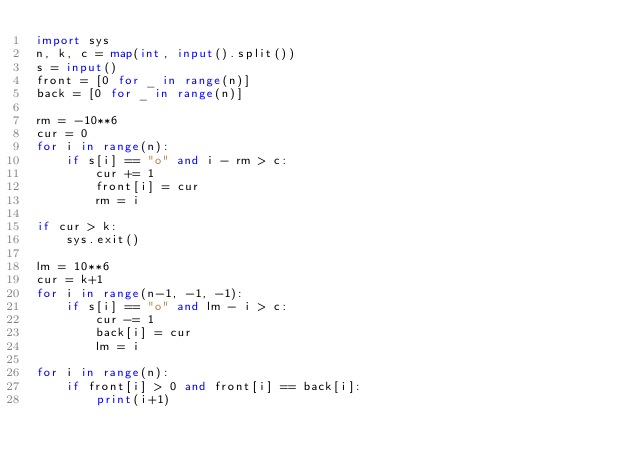Convert code to text. <code><loc_0><loc_0><loc_500><loc_500><_Python_>import sys
n, k, c = map(int, input().split())
s = input()
front = [0 for _ in range(n)]
back = [0 for _ in range(n)]

rm = -10**6
cur = 0
for i in range(n):
	if s[i] == "o" and i - rm > c:
		cur += 1
		front[i] = cur
		rm = i

if cur > k:
	sys.exit()

lm = 10**6
cur = k+1
for i in range(n-1, -1, -1):
	if s[i] == "o" and lm - i > c:
		cur -= 1
		back[i] = cur
		lm = i

for i in range(n):
	if front[i] > 0 and front[i] == back[i]:
		print(i+1)</code> 